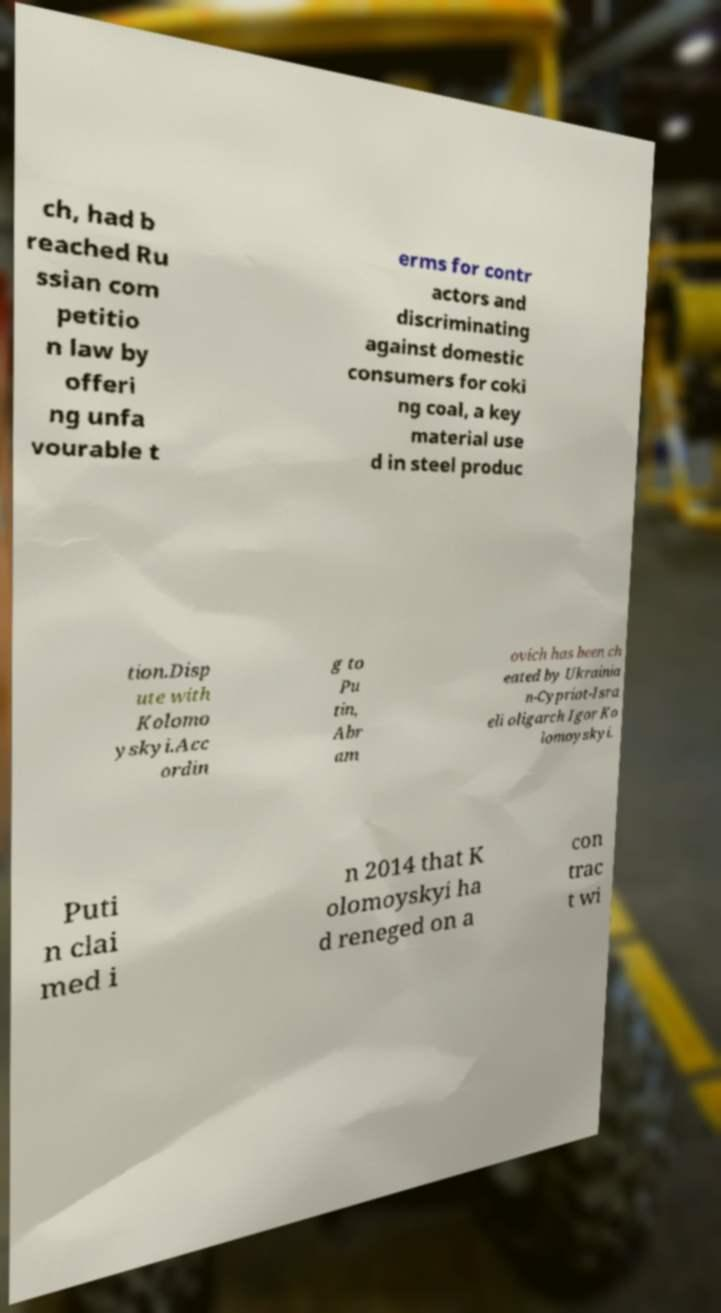Please read and relay the text visible in this image. What does it say? ch, had b reached Ru ssian com petitio n law by offeri ng unfa vourable t erms for contr actors and discriminating against domestic consumers for coki ng coal, a key material use d in steel produc tion.Disp ute with Kolomo yskyi.Acc ordin g to Pu tin, Abr am ovich has been ch eated by Ukrainia n-Cypriot-Isra eli oligarch Igor Ko lomoyskyi. Puti n clai med i n 2014 that K olomoyskyi ha d reneged on a con trac t wi 